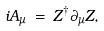<formula> <loc_0><loc_0><loc_500><loc_500>i A _ { \mu } \, = \, Z ^ { \dagger } \partial _ { \mu } Z ,</formula> 